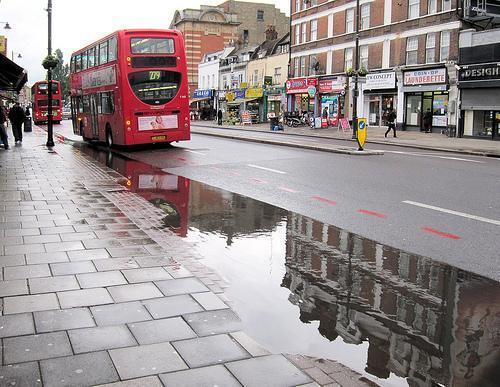How many buses are visible?
Give a very brief answer. 2. 